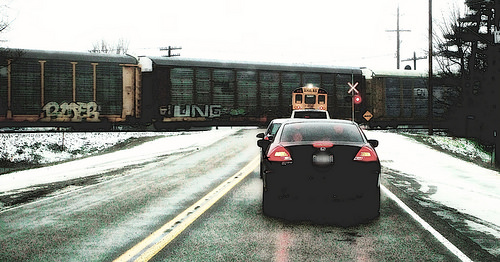<image>
Can you confirm if the car is behind the bus? Yes. From this viewpoint, the car is positioned behind the bus, with the bus partially or fully occluding the car. 